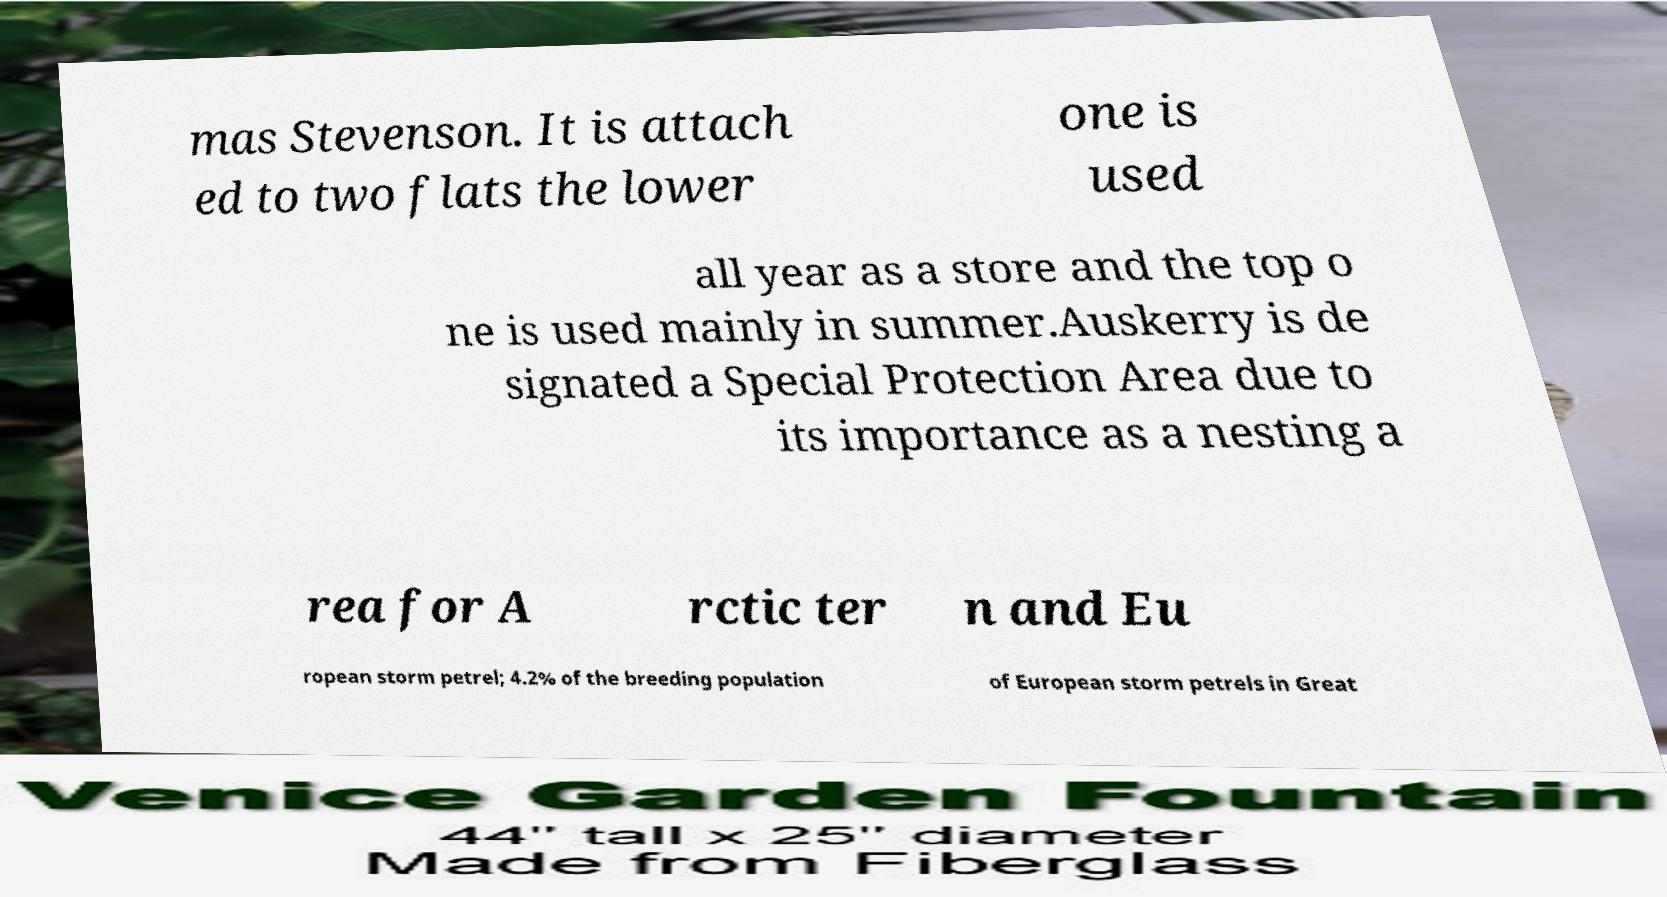Can you read and provide the text displayed in the image?This photo seems to have some interesting text. Can you extract and type it out for me? mas Stevenson. It is attach ed to two flats the lower one is used all year as a store and the top o ne is used mainly in summer.Auskerry is de signated a Special Protection Area due to its importance as a nesting a rea for A rctic ter n and Eu ropean storm petrel; 4.2% of the breeding population of European storm petrels in Great 